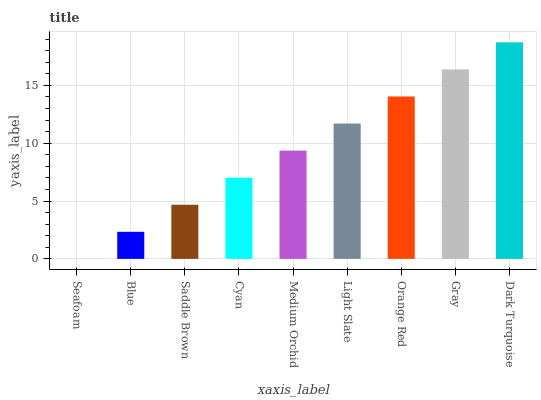Is Seafoam the minimum?
Answer yes or no. Yes. Is Dark Turquoise the maximum?
Answer yes or no. Yes. Is Blue the minimum?
Answer yes or no. No. Is Blue the maximum?
Answer yes or no. No. Is Blue greater than Seafoam?
Answer yes or no. Yes. Is Seafoam less than Blue?
Answer yes or no. Yes. Is Seafoam greater than Blue?
Answer yes or no. No. Is Blue less than Seafoam?
Answer yes or no. No. Is Medium Orchid the high median?
Answer yes or no. Yes. Is Medium Orchid the low median?
Answer yes or no. Yes. Is Blue the high median?
Answer yes or no. No. Is Orange Red the low median?
Answer yes or no. No. 